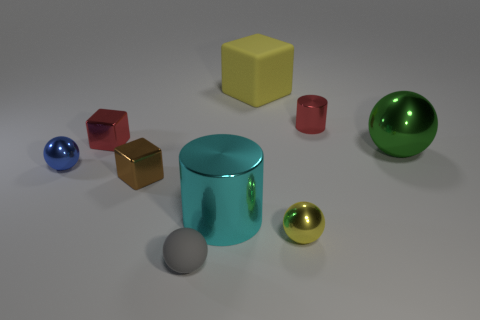Subtract 1 balls. How many balls are left? 3 Add 1 red objects. How many objects exist? 10 Subtract all spheres. How many objects are left? 5 Subtract all blue rubber balls. Subtract all green balls. How many objects are left? 8 Add 3 small matte balls. How many small matte balls are left? 4 Add 8 small gray matte balls. How many small gray matte balls exist? 9 Subtract 0 red spheres. How many objects are left? 9 